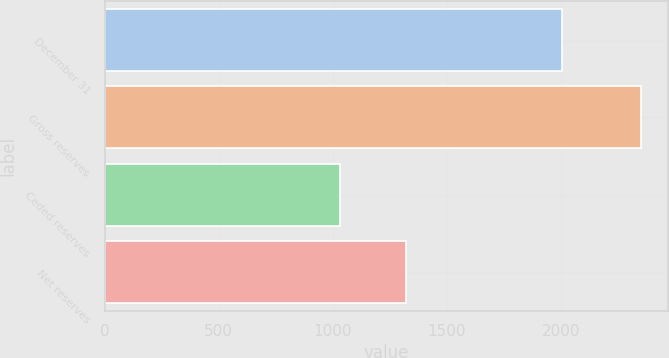Convert chart. <chart><loc_0><loc_0><loc_500><loc_500><bar_chart><fcel>December 31<fcel>Gross reserves<fcel>Ceded reserves<fcel>Net reserves<nl><fcel>2007<fcel>2352<fcel>1030<fcel>1322<nl></chart> 